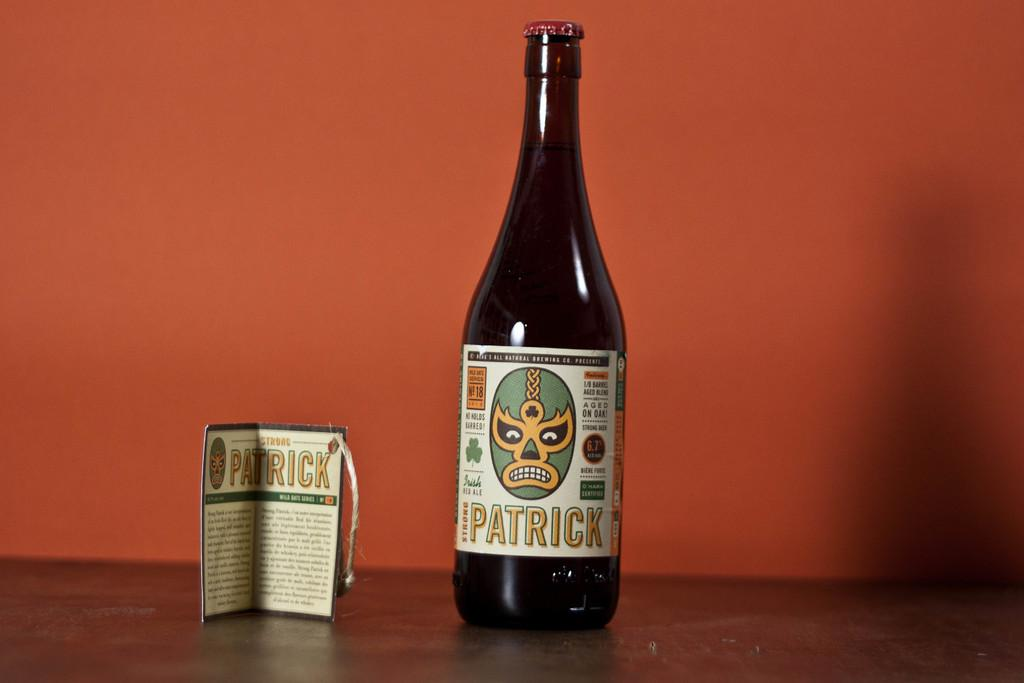<image>
Create a compact narrative representing the image presented. a bottle of alcohol with a book next it of the name patrick 